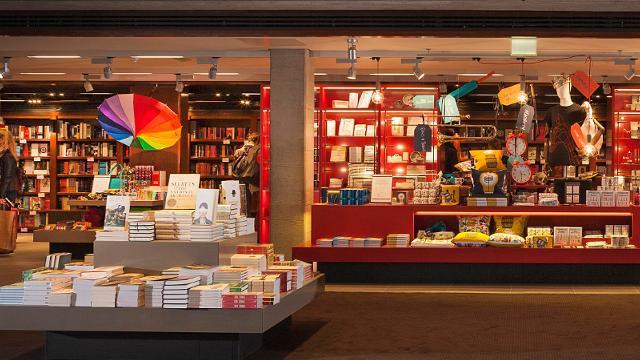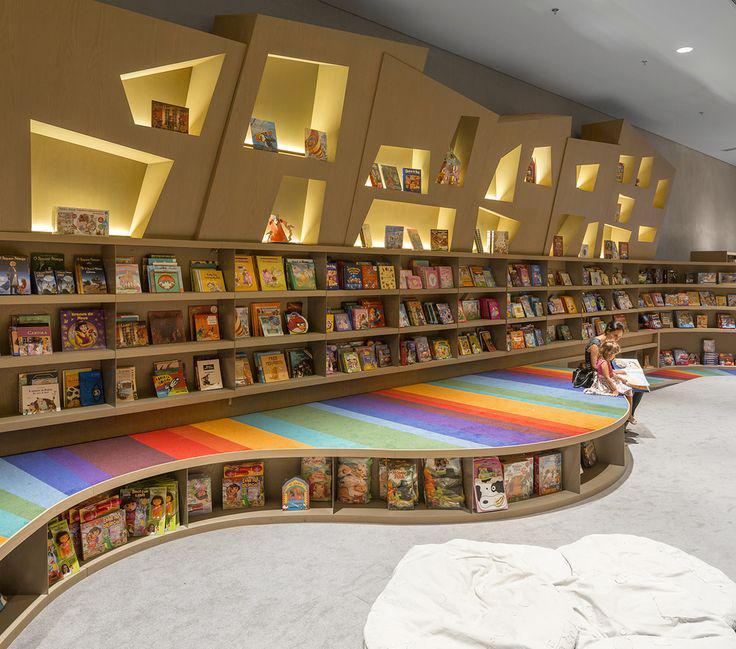The first image is the image on the left, the second image is the image on the right. For the images displayed, is the sentence "There are at least two people in the bookstore, one adult and one child reading." factually correct? Answer yes or no. Yes. 